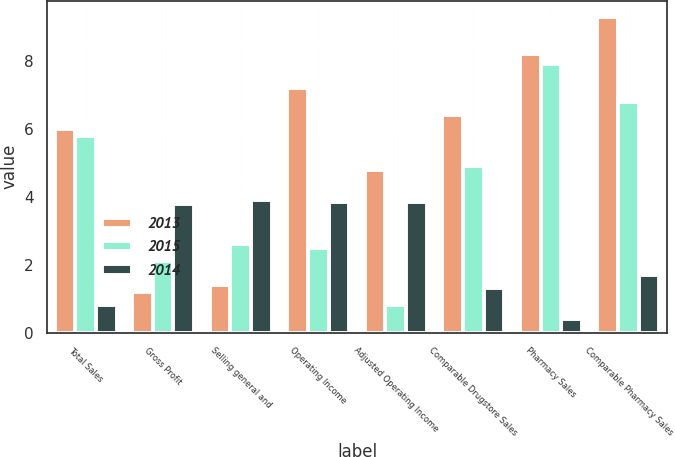<chart> <loc_0><loc_0><loc_500><loc_500><stacked_bar_chart><ecel><fcel>Total Sales<fcel>Gross Profit<fcel>Selling general and<fcel>Operating Income<fcel>Adjusted Operating Income<fcel>Comparable Drugstore Sales<fcel>Pharmacy Sales<fcel>Comparable Pharmacy Sales<nl><fcel>2013<fcel>6<fcel>1.2<fcel>1.4<fcel>7.2<fcel>4.8<fcel>6.4<fcel>8.2<fcel>9.3<nl><fcel>2015<fcel>5.8<fcel>2.1<fcel>2.6<fcel>2.5<fcel>0.8<fcel>4.9<fcel>7.9<fcel>6.8<nl><fcel>2014<fcel>0.8<fcel>3.8<fcel>3.9<fcel>3.85<fcel>3.85<fcel>1.3<fcel>0.4<fcel>1.7<nl></chart> 